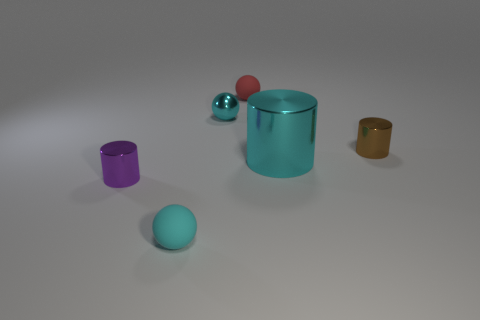There is a rubber object that is in front of the cyan cylinder; is its color the same as the metal object behind the tiny brown shiny thing?
Your answer should be very brief. Yes. Is the color of the large thing the same as the metallic sphere?
Provide a short and direct response. Yes. Is the brown cylinder made of the same material as the tiny red thing?
Keep it short and to the point. No. There is a small matte sphere left of the tiny matte thing that is behind the small cyan rubber sphere; what number of cylinders are right of it?
Give a very brief answer. 2. What number of cyan cylinders are there?
Your response must be concise. 1. Is the number of large cyan cylinders left of the purple metal thing less than the number of small rubber objects in front of the red rubber ball?
Keep it short and to the point. Yes. Is the number of big cyan cylinders that are to the left of the tiny red thing less than the number of red shiny cylinders?
Offer a terse response. No. What material is the large cyan cylinder to the right of the cyan shiny thing behind the tiny shiny cylinder behind the purple cylinder?
Your answer should be compact. Metal. How many objects are either small shiny cylinders on the right side of the small red matte object or tiny rubber objects that are in front of the small brown object?
Your answer should be very brief. 2. What is the material of the tiny purple object that is the same shape as the tiny brown metal object?
Ensure brevity in your answer.  Metal. 